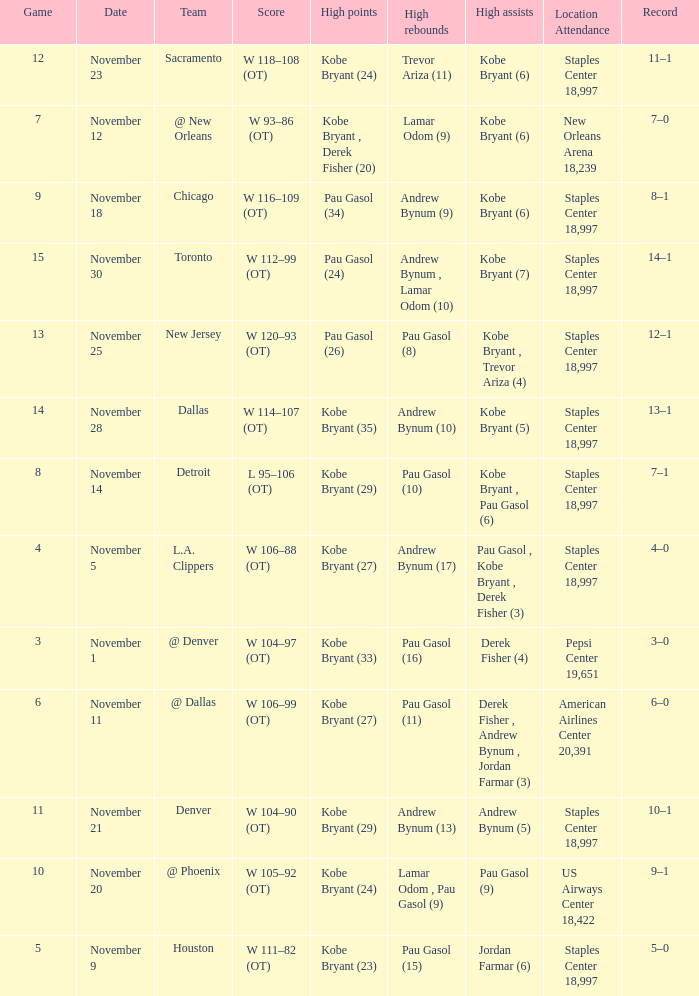I'm looking to parse the entire table for insights. Could you assist me with that? {'header': ['Game', 'Date', 'Team', 'Score', 'High points', 'High rebounds', 'High assists', 'Location Attendance', 'Record'], 'rows': [['12', 'November 23', 'Sacramento', 'W 118–108 (OT)', 'Kobe Bryant (24)', 'Trevor Ariza (11)', 'Kobe Bryant (6)', 'Staples Center 18,997', '11–1'], ['7', 'November 12', '@ New Orleans', 'W 93–86 (OT)', 'Kobe Bryant , Derek Fisher (20)', 'Lamar Odom (9)', 'Kobe Bryant (6)', 'New Orleans Arena 18,239', '7–0'], ['9', 'November 18', 'Chicago', 'W 116–109 (OT)', 'Pau Gasol (34)', 'Andrew Bynum (9)', 'Kobe Bryant (6)', 'Staples Center 18,997', '8–1'], ['15', 'November 30', 'Toronto', 'W 112–99 (OT)', 'Pau Gasol (24)', 'Andrew Bynum , Lamar Odom (10)', 'Kobe Bryant (7)', 'Staples Center 18,997', '14–1'], ['13', 'November 25', 'New Jersey', 'W 120–93 (OT)', 'Pau Gasol (26)', 'Pau Gasol (8)', 'Kobe Bryant , Trevor Ariza (4)', 'Staples Center 18,997', '12–1'], ['14', 'November 28', 'Dallas', 'W 114–107 (OT)', 'Kobe Bryant (35)', 'Andrew Bynum (10)', 'Kobe Bryant (5)', 'Staples Center 18,997', '13–1'], ['8', 'November 14', 'Detroit', 'L 95–106 (OT)', 'Kobe Bryant (29)', 'Pau Gasol (10)', 'Kobe Bryant , Pau Gasol (6)', 'Staples Center 18,997', '7–1'], ['4', 'November 5', 'L.A. Clippers', 'W 106–88 (OT)', 'Kobe Bryant (27)', 'Andrew Bynum (17)', 'Pau Gasol , Kobe Bryant , Derek Fisher (3)', 'Staples Center 18,997', '4–0'], ['3', 'November 1', '@ Denver', 'W 104–97 (OT)', 'Kobe Bryant (33)', 'Pau Gasol (16)', 'Derek Fisher (4)', 'Pepsi Center 19,651', '3–0'], ['6', 'November 11', '@ Dallas', 'W 106–99 (OT)', 'Kobe Bryant (27)', 'Pau Gasol (11)', 'Derek Fisher , Andrew Bynum , Jordan Farmar (3)', 'American Airlines Center 20,391', '6–0'], ['11', 'November 21', 'Denver', 'W 104–90 (OT)', 'Kobe Bryant (29)', 'Andrew Bynum (13)', 'Andrew Bynum (5)', 'Staples Center 18,997', '10–1'], ['10', 'November 20', '@ Phoenix', 'W 105–92 (OT)', 'Kobe Bryant (24)', 'Lamar Odom , Pau Gasol (9)', 'Pau Gasol (9)', 'US Airways Center 18,422', '9–1'], ['5', 'November 9', 'Houston', 'W 111–82 (OT)', 'Kobe Bryant (23)', 'Pau Gasol (15)', 'Jordan Farmar (6)', 'Staples Center 18,997', '5–0']]} What is High Assists, when High Points is "Kobe Bryant (27)", and when High Rebounds is "Pau Gasol (11)"? Derek Fisher , Andrew Bynum , Jordan Farmar (3). 